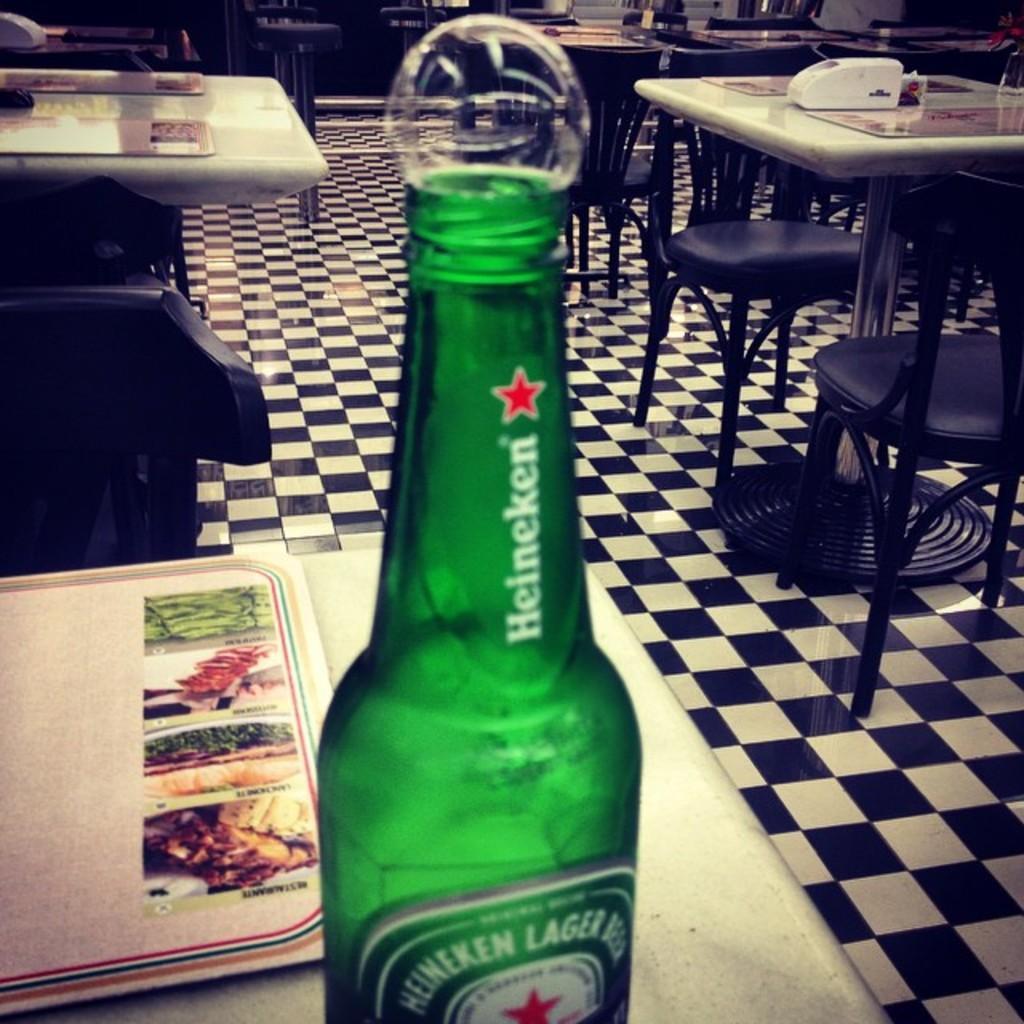In one or two sentences, can you explain what this image depicts? In the picture we can see some tables and a table we can find a bottle which is green in colour, beside that there is a menu card, and they are some chairs also on the floor. 